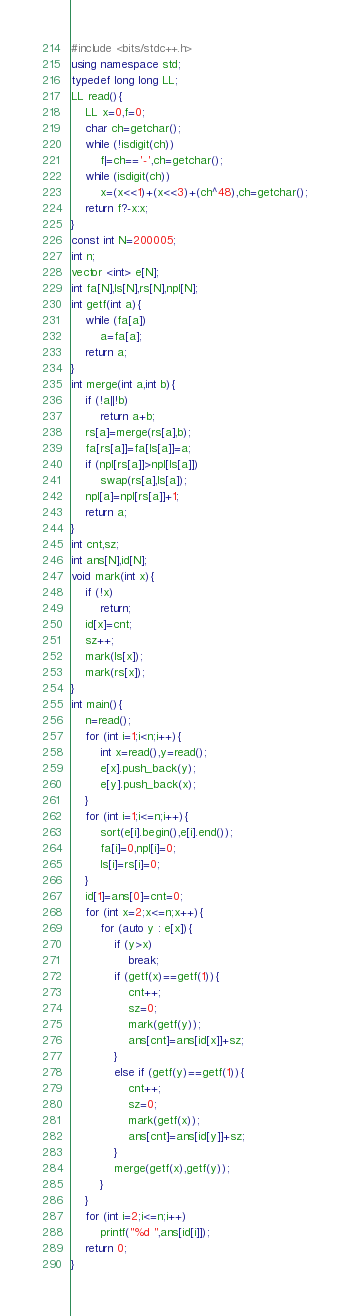Convert code to text. <code><loc_0><loc_0><loc_500><loc_500><_C++_>#include <bits/stdc++.h>
using namespace std;
typedef long long LL;
LL read(){
	LL x=0,f=0;
	char ch=getchar();
	while (!isdigit(ch))
		f|=ch=='-',ch=getchar();
	while (isdigit(ch))
		x=(x<<1)+(x<<3)+(ch^48),ch=getchar();
	return f?-x:x;
}
const int N=200005;
int n;
vector <int> e[N];
int fa[N],ls[N],rs[N],npl[N];
int getf(int a){
    while (fa[a])
        a=fa[a];
    return a;
}
int merge(int a,int b){
    if (!a||!b)
        return a+b;
    rs[a]=merge(rs[a],b);
    fa[rs[a]]=fa[ls[a]]=a;
    if (npl[rs[a]]>npl[ls[a]])
        swap(rs[a],ls[a]);
    npl[a]=npl[rs[a]]+1;
    return a;
}
int cnt,sz;
int ans[N],id[N];
void mark(int x){
	if (!x)
		return;
	id[x]=cnt;
	sz++;
	mark(ls[x]);
	mark(rs[x]);
}
int main(){
	n=read();
	for (int i=1;i<n;i++){
		int x=read(),y=read();
		e[x].push_back(y);
		e[y].push_back(x);
	}
	for (int i=1;i<=n;i++){
		sort(e[i].begin(),e[i].end());
		fa[i]=0,npl[i]=0;
		ls[i]=rs[i]=0;
	}
	id[1]=ans[0]=cnt=0;
	for (int x=2;x<=n;x++){
		for (auto y : e[x]){
			if (y>x)
				break;
			if (getf(x)==getf(1)){
				cnt++;
				sz=0;
				mark(getf(y));
				ans[cnt]=ans[id[x]]+sz;
			}
			else if (getf(y)==getf(1)){
				cnt++;
				sz=0;
				mark(getf(x));
				ans[cnt]=ans[id[y]]+sz;
			}
			merge(getf(x),getf(y));
		}
	}
	for (int i=2;i<=n;i++)
		printf("%d ",ans[id[i]]);
	return 0;
}</code> 